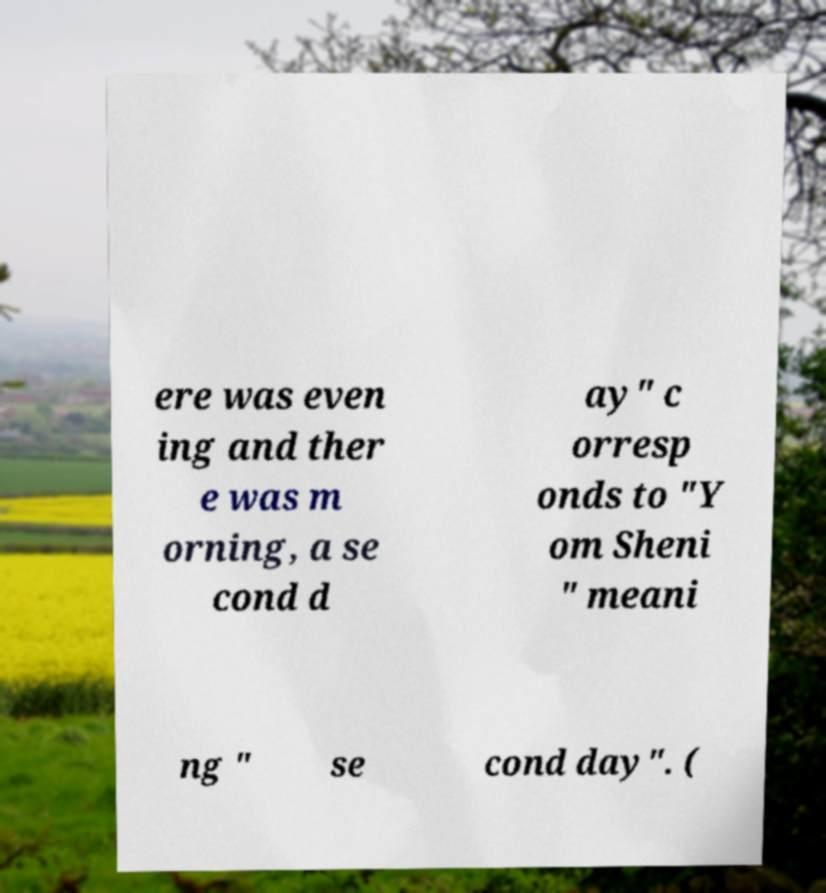Could you extract and type out the text from this image? ere was even ing and ther e was m orning, a se cond d ay" c orresp onds to "Y om Sheni " meani ng " se cond day". ( 